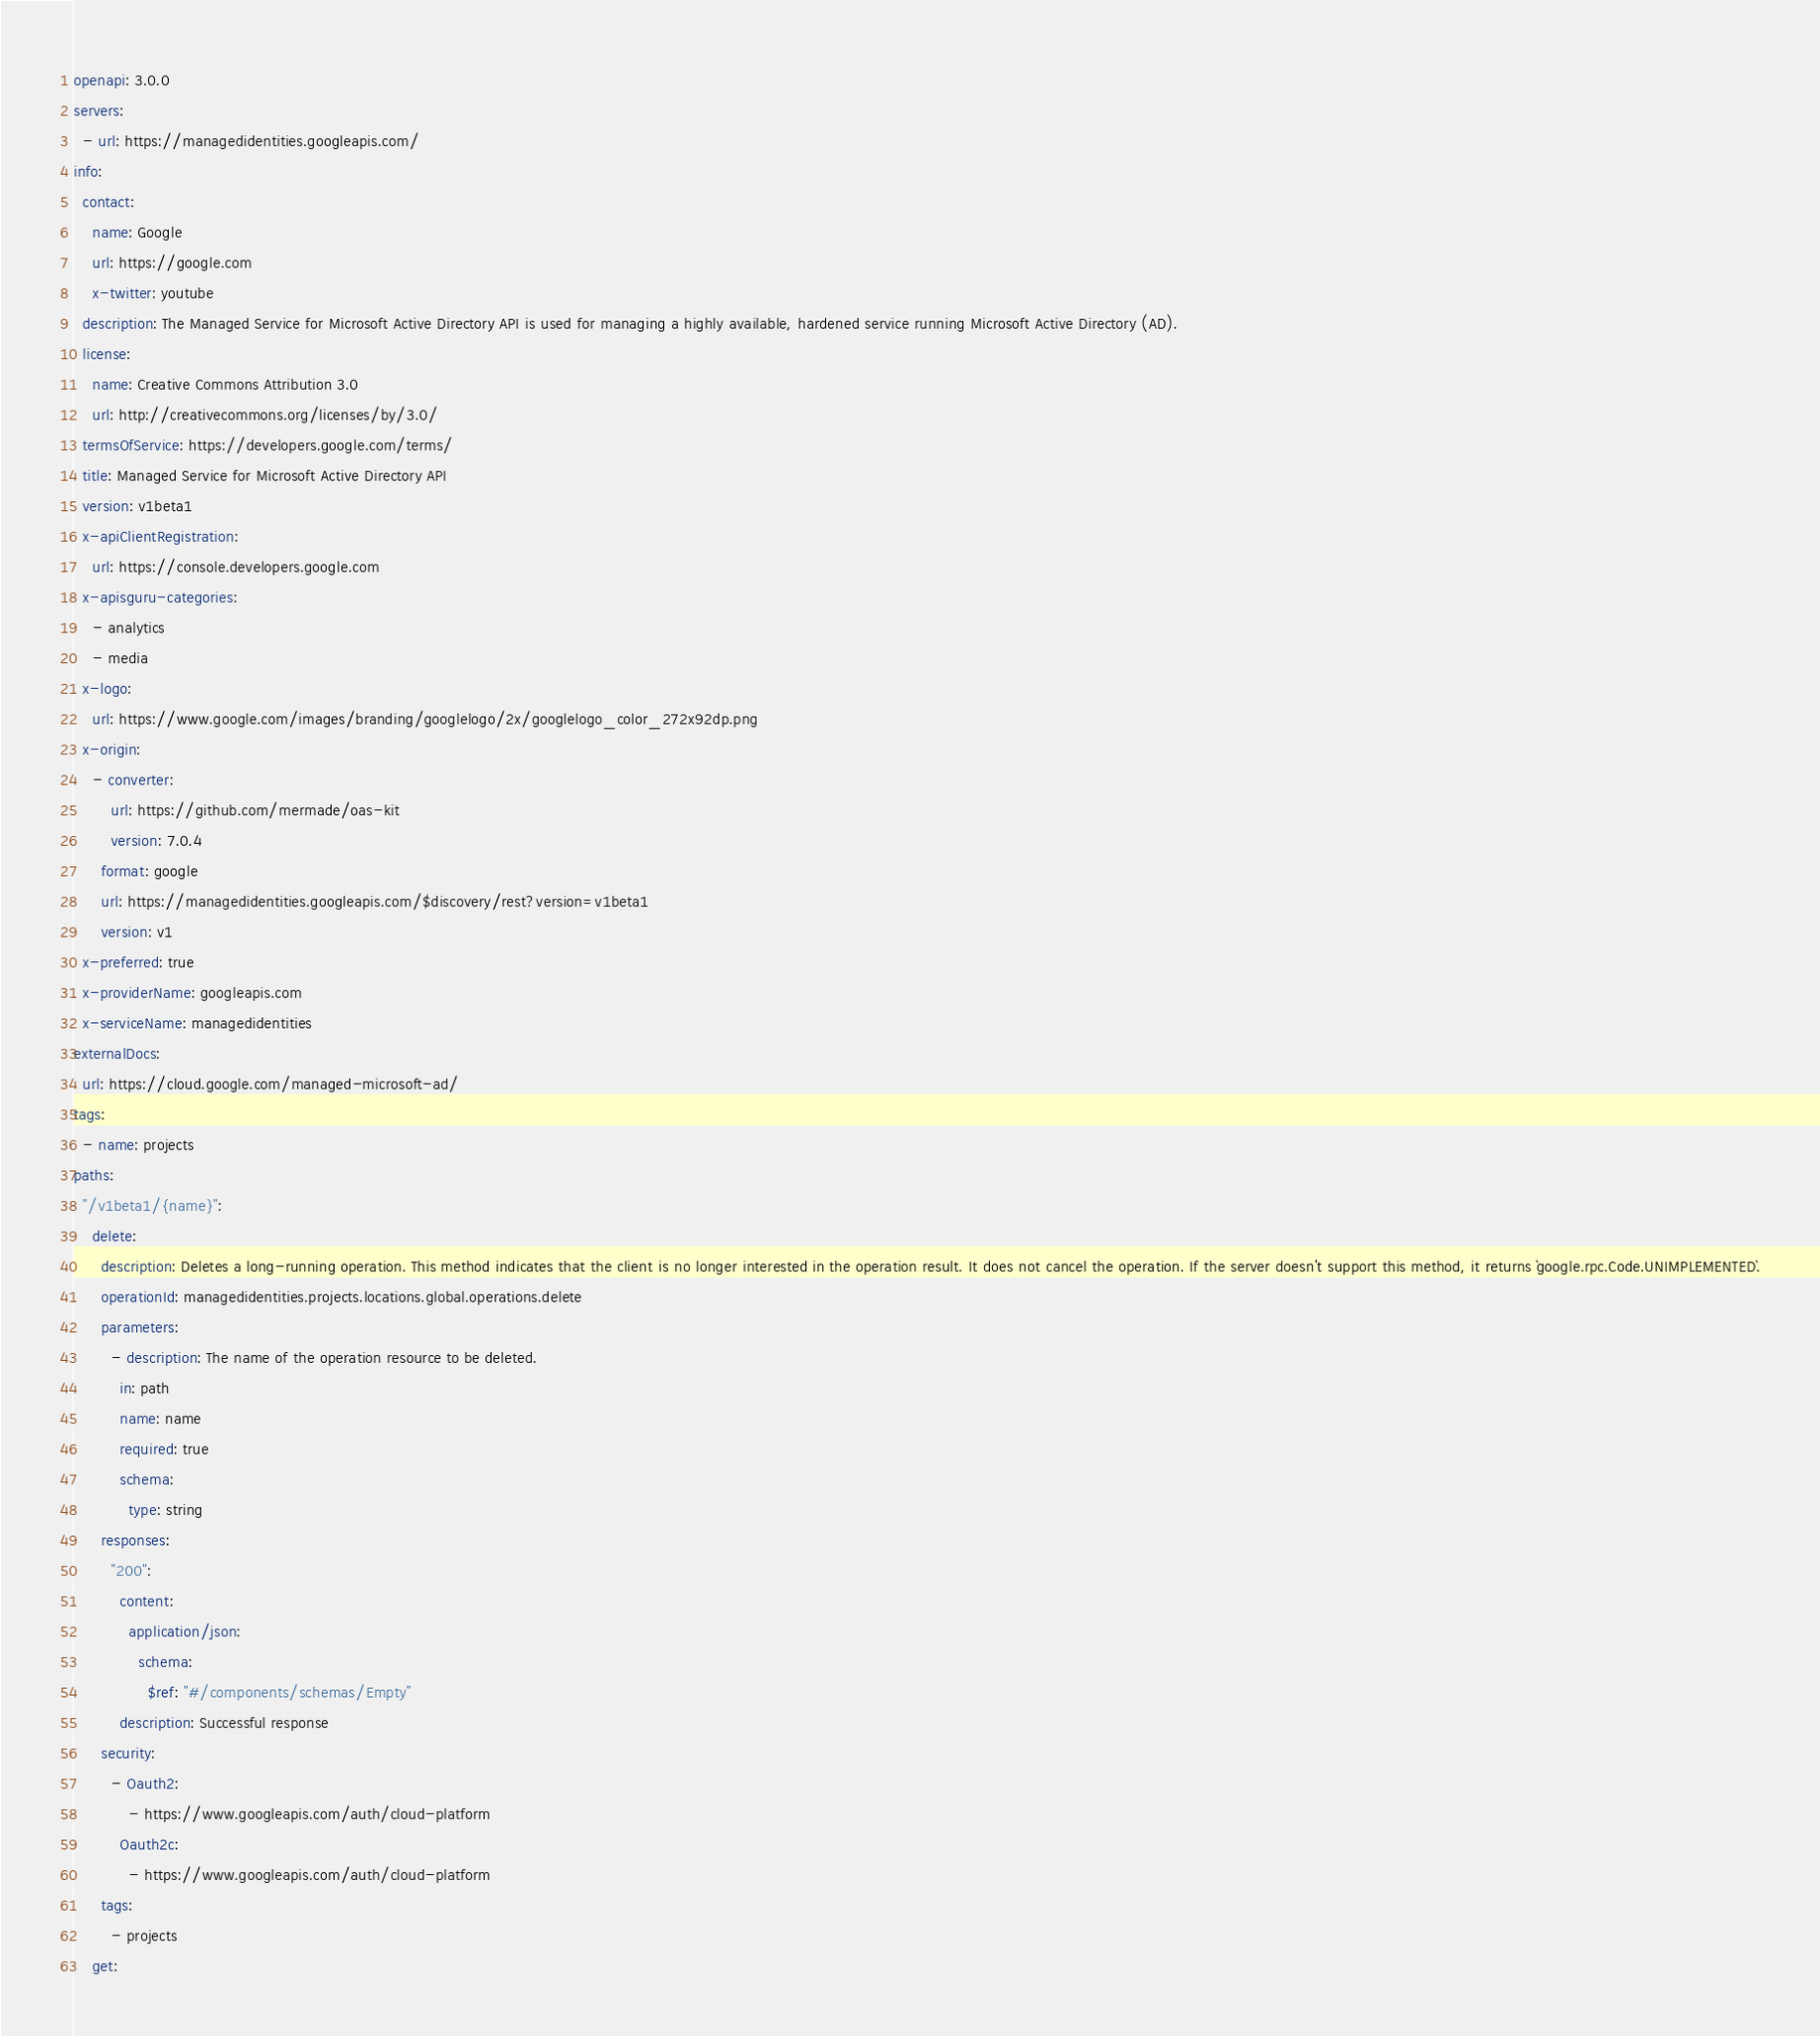<code> <loc_0><loc_0><loc_500><loc_500><_YAML_>openapi: 3.0.0
servers:
  - url: https://managedidentities.googleapis.com/
info:
  contact:
    name: Google
    url: https://google.com
    x-twitter: youtube
  description: The Managed Service for Microsoft Active Directory API is used for managing a highly available, hardened service running Microsoft Active Directory (AD).
  license:
    name: Creative Commons Attribution 3.0
    url: http://creativecommons.org/licenses/by/3.0/
  termsOfService: https://developers.google.com/terms/
  title: Managed Service for Microsoft Active Directory API
  version: v1beta1
  x-apiClientRegistration:
    url: https://console.developers.google.com
  x-apisguru-categories:
    - analytics
    - media
  x-logo:
    url: https://www.google.com/images/branding/googlelogo/2x/googlelogo_color_272x92dp.png
  x-origin:
    - converter:
        url: https://github.com/mermade/oas-kit
        version: 7.0.4
      format: google
      url: https://managedidentities.googleapis.com/$discovery/rest?version=v1beta1
      version: v1
  x-preferred: true
  x-providerName: googleapis.com
  x-serviceName: managedidentities
externalDocs:
  url: https://cloud.google.com/managed-microsoft-ad/
tags:
  - name: projects
paths:
  "/v1beta1/{name}":
    delete:
      description: Deletes a long-running operation. This method indicates that the client is no longer interested in the operation result. It does not cancel the operation. If the server doesn't support this method, it returns `google.rpc.Code.UNIMPLEMENTED`.
      operationId: managedidentities.projects.locations.global.operations.delete
      parameters:
        - description: The name of the operation resource to be deleted.
          in: path
          name: name
          required: true
          schema:
            type: string
      responses:
        "200":
          content:
            application/json:
              schema:
                $ref: "#/components/schemas/Empty"
          description: Successful response
      security:
        - Oauth2:
            - https://www.googleapis.com/auth/cloud-platform
          Oauth2c:
            - https://www.googleapis.com/auth/cloud-platform
      tags:
        - projects
    get:</code> 